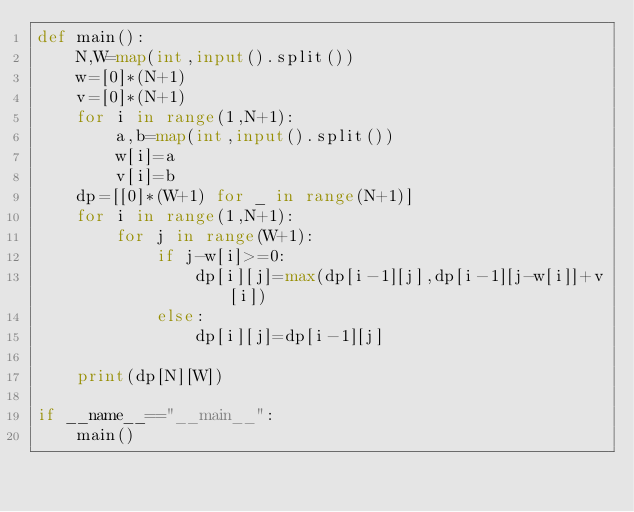Convert code to text. <code><loc_0><loc_0><loc_500><loc_500><_Python_>def main():
    N,W=map(int,input().split())
    w=[0]*(N+1)
    v=[0]*(N+1)
    for i in range(1,N+1):
        a,b=map(int,input().split())
        w[i]=a
        v[i]=b
    dp=[[0]*(W+1) for _ in range(N+1)]
    for i in range(1,N+1):
        for j in range(W+1):
            if j-w[i]>=0:
                dp[i][j]=max(dp[i-1][j],dp[i-1][j-w[i]]+v[i])
            else:
                dp[i][j]=dp[i-1][j]

    print(dp[N][W])

if __name__=="__main__":
    main()</code> 